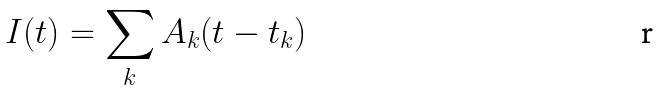Convert formula to latex. <formula><loc_0><loc_0><loc_500><loc_500>I ( t ) = \sum _ { k } A _ { k } ( t - t _ { k } )</formula> 